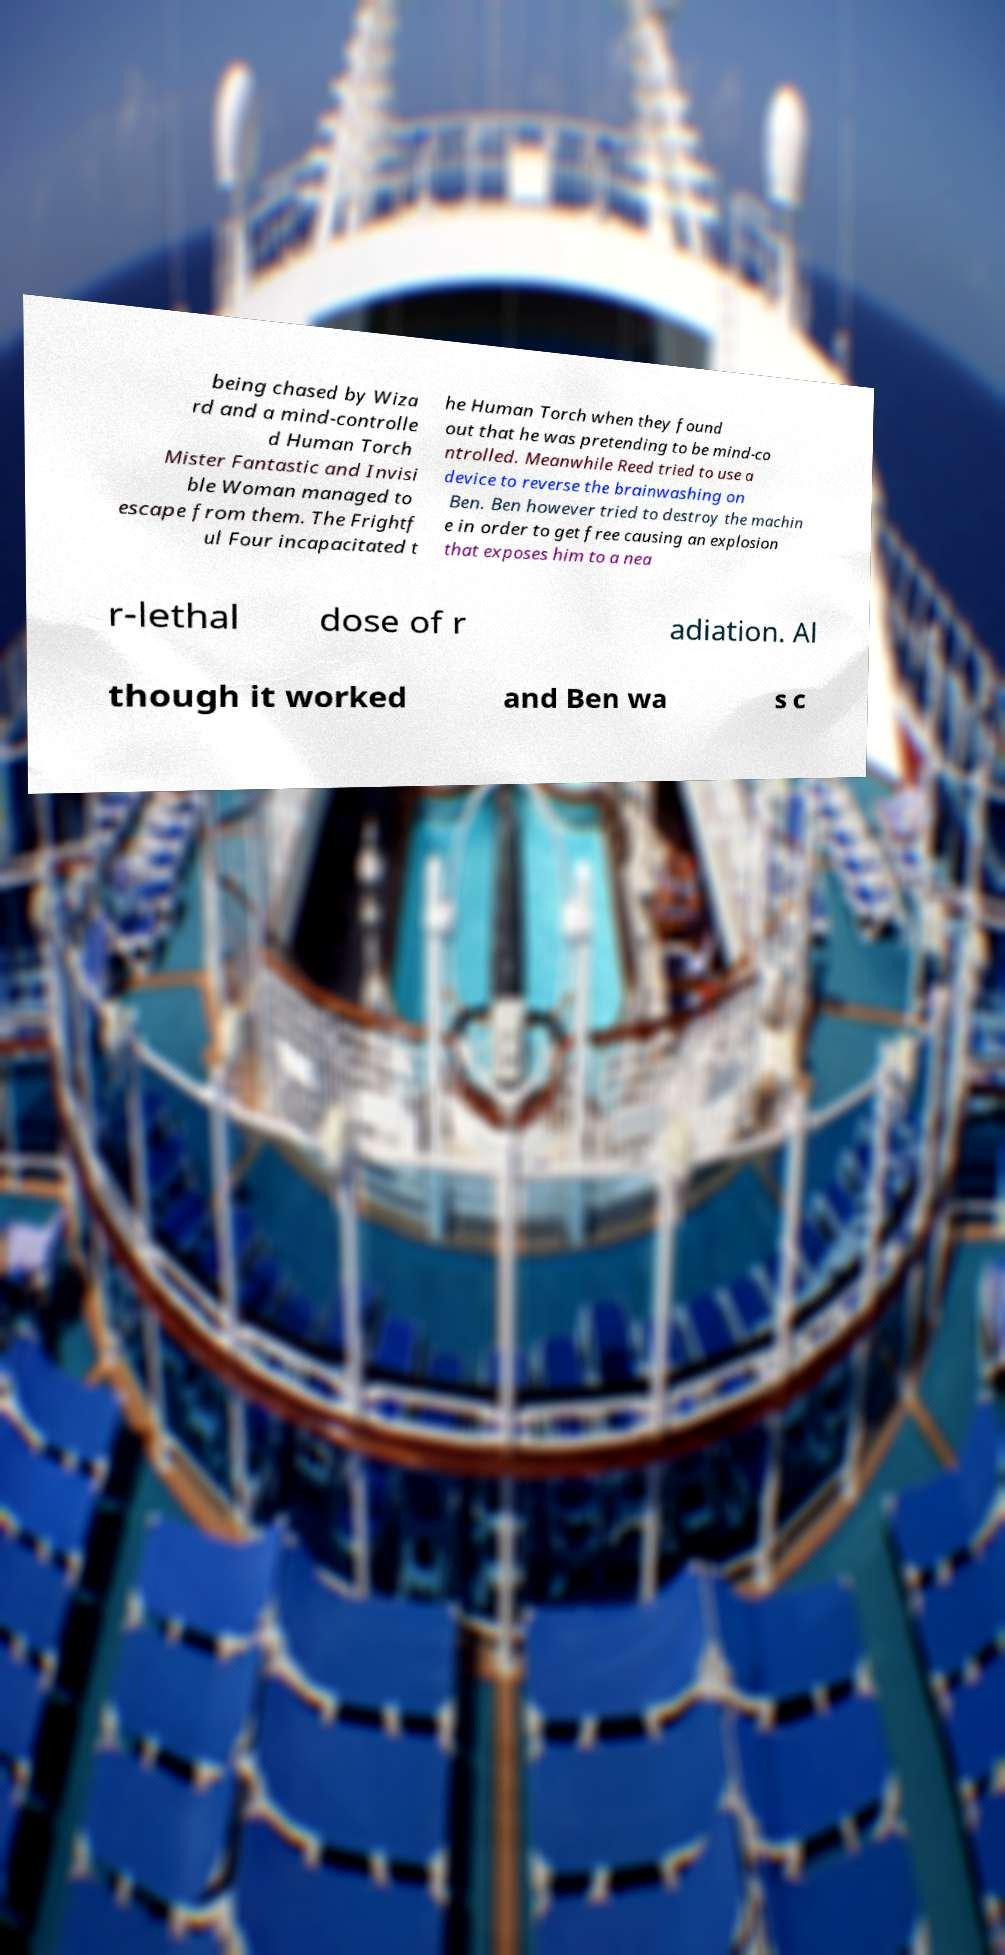Please identify and transcribe the text found in this image. being chased by Wiza rd and a mind-controlle d Human Torch Mister Fantastic and Invisi ble Woman managed to escape from them. The Frightf ul Four incapacitated t he Human Torch when they found out that he was pretending to be mind-co ntrolled. Meanwhile Reed tried to use a device to reverse the brainwashing on Ben. Ben however tried to destroy the machin e in order to get free causing an explosion that exposes him to a nea r-lethal dose of r adiation. Al though it worked and Ben wa s c 